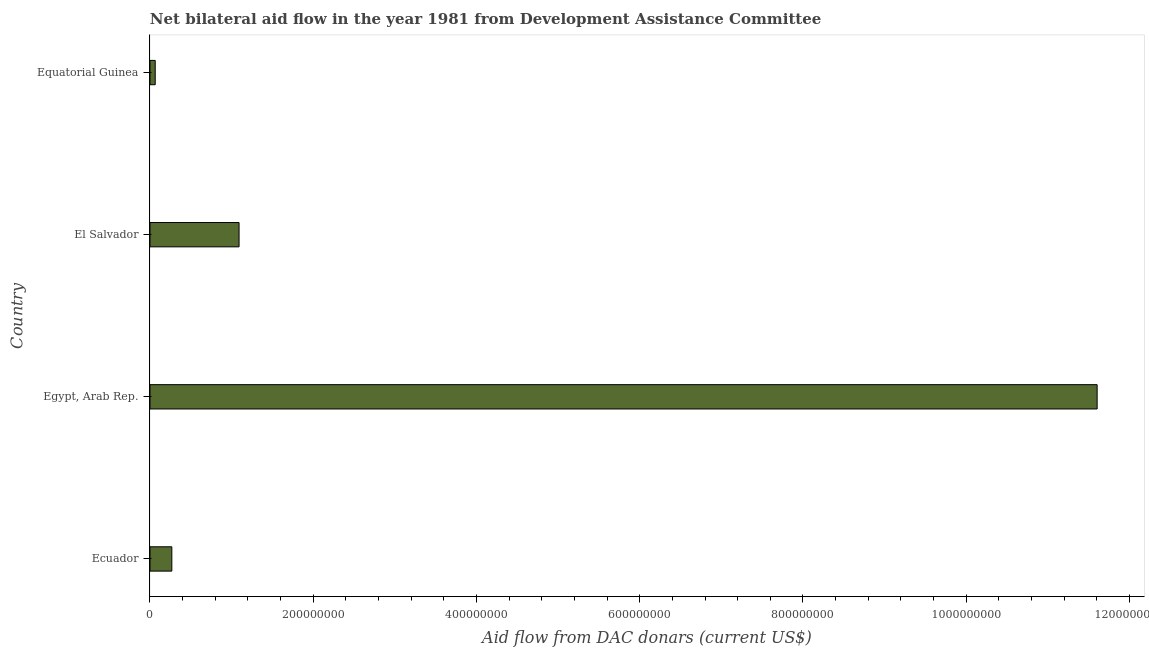Does the graph contain any zero values?
Your answer should be compact. No. Does the graph contain grids?
Offer a very short reply. No. What is the title of the graph?
Offer a very short reply. Net bilateral aid flow in the year 1981 from Development Assistance Committee. What is the label or title of the X-axis?
Ensure brevity in your answer.  Aid flow from DAC donars (current US$). What is the net bilateral aid flows from dac donors in Egypt, Arab Rep.?
Ensure brevity in your answer.  1.16e+09. Across all countries, what is the maximum net bilateral aid flows from dac donors?
Provide a succinct answer. 1.16e+09. Across all countries, what is the minimum net bilateral aid flows from dac donors?
Your answer should be very brief. 6.40e+06. In which country was the net bilateral aid flows from dac donors maximum?
Your answer should be very brief. Egypt, Arab Rep. In which country was the net bilateral aid flows from dac donors minimum?
Your answer should be very brief. Equatorial Guinea. What is the sum of the net bilateral aid flows from dac donors?
Ensure brevity in your answer.  1.30e+09. What is the difference between the net bilateral aid flows from dac donors in Egypt, Arab Rep. and Equatorial Guinea?
Provide a succinct answer. 1.15e+09. What is the average net bilateral aid flows from dac donors per country?
Ensure brevity in your answer.  3.26e+08. What is the median net bilateral aid flows from dac donors?
Your answer should be compact. 6.79e+07. In how many countries, is the net bilateral aid flows from dac donors greater than 120000000 US$?
Give a very brief answer. 1. What is the ratio of the net bilateral aid flows from dac donors in Ecuador to that in El Salvador?
Your answer should be very brief. 0.24. Is the difference between the net bilateral aid flows from dac donors in Egypt, Arab Rep. and El Salvador greater than the difference between any two countries?
Make the answer very short. No. What is the difference between the highest and the second highest net bilateral aid flows from dac donors?
Your response must be concise. 1.05e+09. Is the sum of the net bilateral aid flows from dac donors in Ecuador and Equatorial Guinea greater than the maximum net bilateral aid flows from dac donors across all countries?
Your response must be concise. No. What is the difference between the highest and the lowest net bilateral aid flows from dac donors?
Your answer should be compact. 1.15e+09. In how many countries, is the net bilateral aid flows from dac donors greater than the average net bilateral aid flows from dac donors taken over all countries?
Keep it short and to the point. 1. How many bars are there?
Make the answer very short. 4. Are all the bars in the graph horizontal?
Ensure brevity in your answer.  Yes. Are the values on the major ticks of X-axis written in scientific E-notation?
Give a very brief answer. No. What is the Aid flow from DAC donars (current US$) of Ecuador?
Offer a terse response. 2.68e+07. What is the Aid flow from DAC donars (current US$) of Egypt, Arab Rep.?
Offer a terse response. 1.16e+09. What is the Aid flow from DAC donars (current US$) of El Salvador?
Offer a very short reply. 1.09e+08. What is the Aid flow from DAC donars (current US$) of Equatorial Guinea?
Keep it short and to the point. 6.40e+06. What is the difference between the Aid flow from DAC donars (current US$) in Ecuador and Egypt, Arab Rep.?
Keep it short and to the point. -1.13e+09. What is the difference between the Aid flow from DAC donars (current US$) in Ecuador and El Salvador?
Keep it short and to the point. -8.24e+07. What is the difference between the Aid flow from DAC donars (current US$) in Ecuador and Equatorial Guinea?
Offer a terse response. 2.04e+07. What is the difference between the Aid flow from DAC donars (current US$) in Egypt, Arab Rep. and El Salvador?
Give a very brief answer. 1.05e+09. What is the difference between the Aid flow from DAC donars (current US$) in Egypt, Arab Rep. and Equatorial Guinea?
Your response must be concise. 1.15e+09. What is the difference between the Aid flow from DAC donars (current US$) in El Salvador and Equatorial Guinea?
Provide a short and direct response. 1.03e+08. What is the ratio of the Aid flow from DAC donars (current US$) in Ecuador to that in Egypt, Arab Rep.?
Offer a very short reply. 0.02. What is the ratio of the Aid flow from DAC donars (current US$) in Ecuador to that in El Salvador?
Your response must be concise. 0.24. What is the ratio of the Aid flow from DAC donars (current US$) in Ecuador to that in Equatorial Guinea?
Provide a succinct answer. 4.18. What is the ratio of the Aid flow from DAC donars (current US$) in Egypt, Arab Rep. to that in El Salvador?
Keep it short and to the point. 10.63. What is the ratio of the Aid flow from DAC donars (current US$) in Egypt, Arab Rep. to that in Equatorial Guinea?
Offer a terse response. 181.32. What is the ratio of the Aid flow from DAC donars (current US$) in El Salvador to that in Equatorial Guinea?
Offer a very short reply. 17.05. 